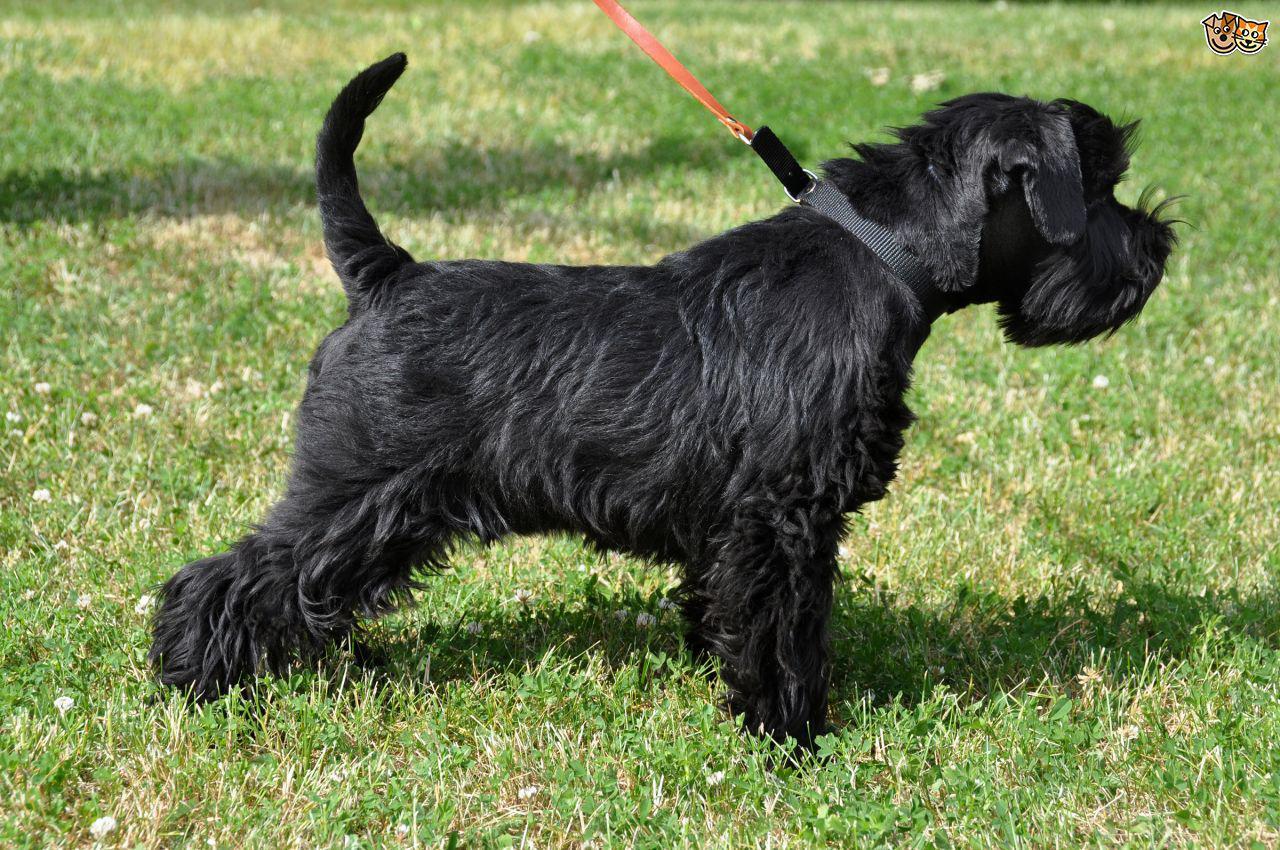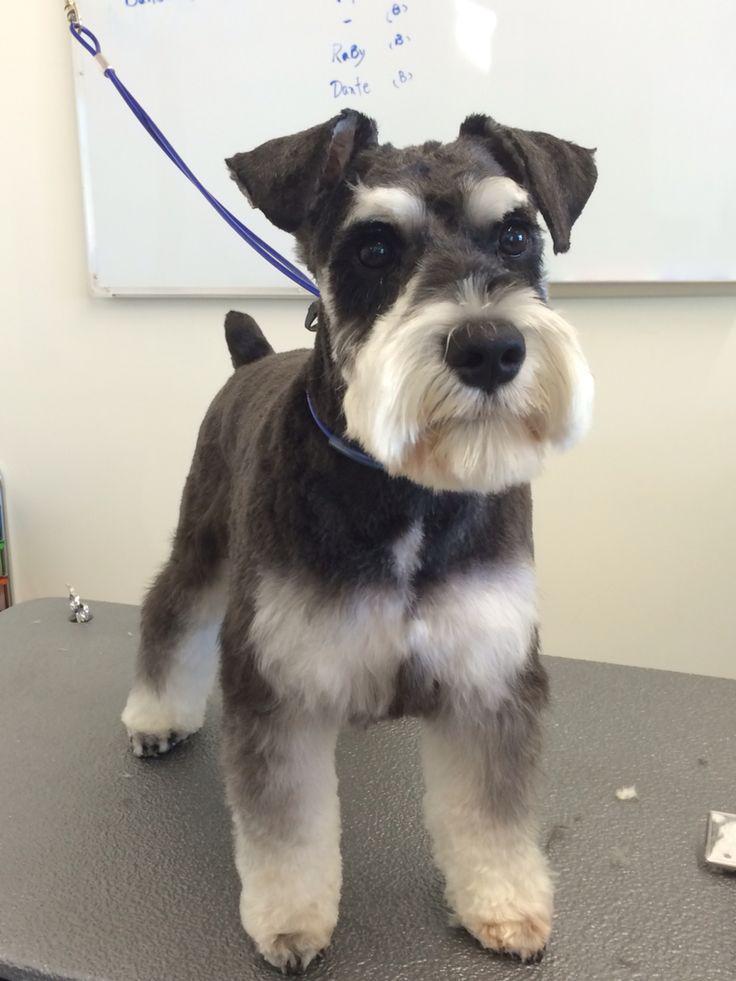The first image is the image on the left, the second image is the image on the right. For the images shown, is this caption "Both dogs are attached to a leash." true? Answer yes or no. Yes. The first image is the image on the left, the second image is the image on the right. Given the left and right images, does the statement "Each image shows a leash extending from the left to a standing schnauzer dog." hold true? Answer yes or no. Yes. 